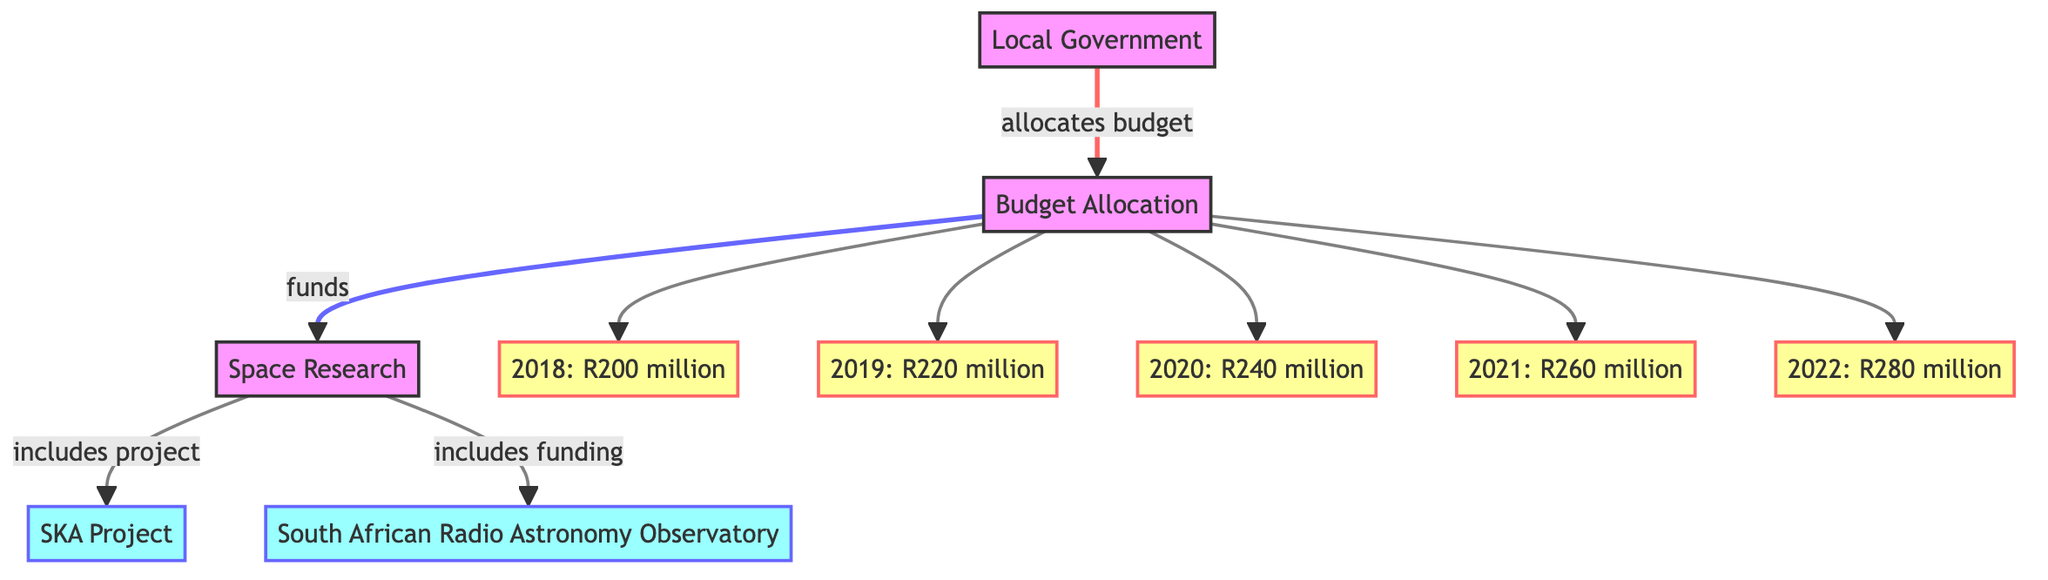What is the total budget allocated for space research in 2020? The diagram shows that the budget allocation for space research in 2020 is specified as R240 million.
Answer: R240 million Which project is part of space research funding? The diagram indicates that the SKA Project is one of the projects included within space research funding.
Answer: SKA Project How much was the budget allocation in 2019? According to the diagram, the budget allocation for the year 2019 is R220 million.
Answer: R220 million How many years are represented in the diagram? The diagram contains budget allocations for five years: 2018, 2019, 2020, 2021, and 2022, totaling to five distinct years.
Answer: 5 What is the trend in budget allocation from 2018 to 2022? The budget increases each year, starting from R200 million in 2018 and reaching R280 million in 2022, indicating a consistent upward trend in the budget allocation.
Answer: Increasing Which organization benefits from the allocated budget according to the diagram? The South African Radio Astronomy Observatory (SAR) is identified as one of the beneficiaries of the allocated budget in the diagram.
Answer: South African Radio Astronomy Observatory What is the allocated budget for 2021? The diagram specifies that the budget allocation for the year 2021 is R260 million.
Answer: R260 million Identify the main entity that allocates the budget in the diagram. The Local Government is identified as the main entity responsible for allocating the budget according to the diagram.
Answer: Local Government 